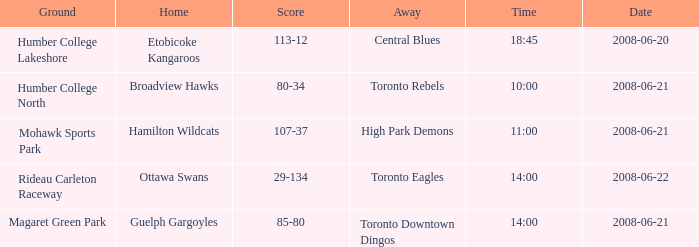Parse the full table. {'header': ['Ground', 'Home', 'Score', 'Away', 'Time', 'Date'], 'rows': [['Humber College Lakeshore', 'Etobicoke Kangaroos', '113-12', 'Central Blues', '18:45', '2008-06-20'], ['Humber College North', 'Broadview Hawks', '80-34', 'Toronto Rebels', '10:00', '2008-06-21'], ['Mohawk Sports Park', 'Hamilton Wildcats', '107-37', 'High Park Demons', '11:00', '2008-06-21'], ['Rideau Carleton Raceway', 'Ottawa Swans', '29-134', 'Toronto Eagles', '14:00', '2008-06-22'], ['Magaret Green Park', 'Guelph Gargoyles', '85-80', 'Toronto Downtown Dingos', '14:00', '2008-06-21']]} What is the Time with a Ground that is humber college north? 10:00. 